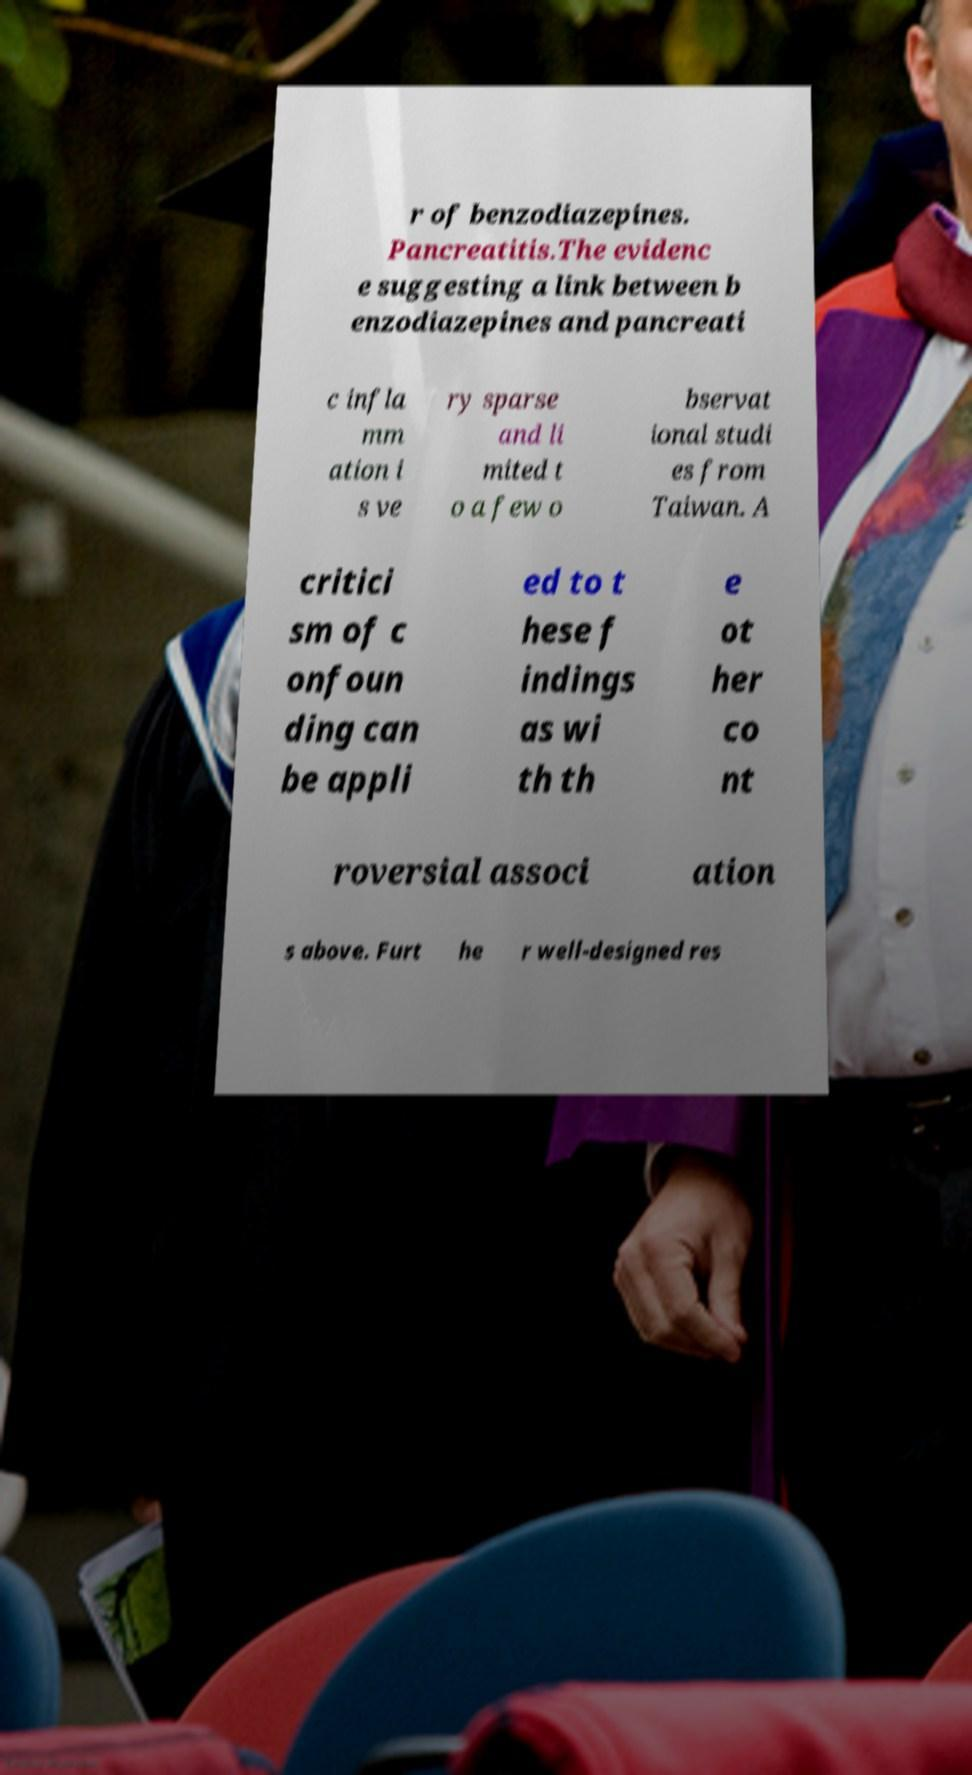What messages or text are displayed in this image? I need them in a readable, typed format. r of benzodiazepines. Pancreatitis.The evidenc e suggesting a link between b enzodiazepines and pancreati c infla mm ation i s ve ry sparse and li mited t o a few o bservat ional studi es from Taiwan. A critici sm of c onfoun ding can be appli ed to t hese f indings as wi th th e ot her co nt roversial associ ation s above. Furt he r well-designed res 